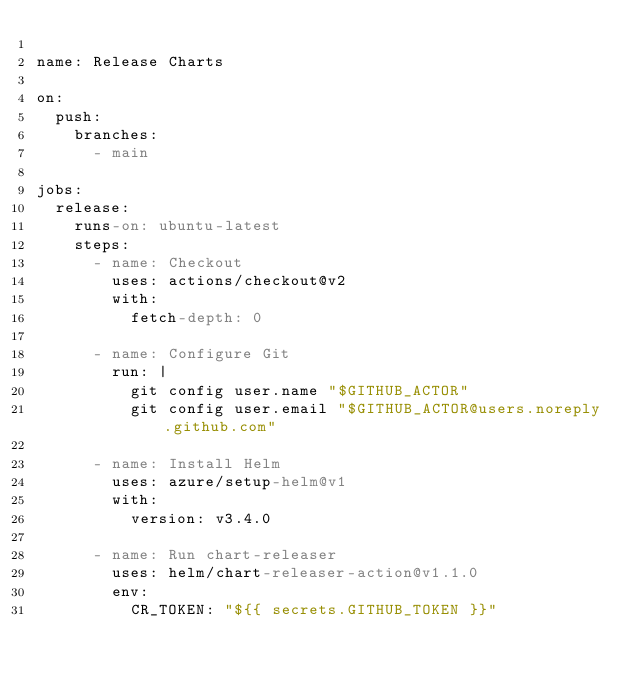<code> <loc_0><loc_0><loc_500><loc_500><_YAML_>
name: Release Charts

on:
  push:
    branches: 
      - main

jobs:
  release:
    runs-on: ubuntu-latest
    steps:
      - name: Checkout
        uses: actions/checkout@v2
        with:
          fetch-depth: 0

      - name: Configure Git
        run: |
          git config user.name "$GITHUB_ACTOR"
          git config user.email "$GITHUB_ACTOR@users.noreply.github.com"

      - name: Install Helm
        uses: azure/setup-helm@v1
        with:
          version: v3.4.0

      - name: Run chart-releaser
        uses: helm/chart-releaser-action@v1.1.0
        env:
          CR_TOKEN: "${{ secrets.GITHUB_TOKEN }}"
</code> 